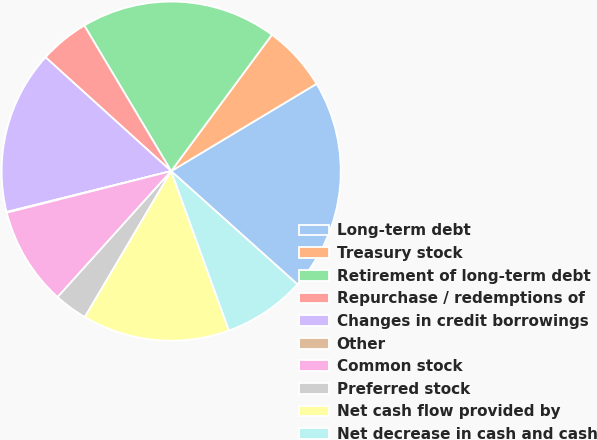Convert chart to OTSL. <chart><loc_0><loc_0><loc_500><loc_500><pie_chart><fcel>Long-term debt<fcel>Treasury stock<fcel>Retirement of long-term debt<fcel>Repurchase / redemptions of<fcel>Changes in credit borrowings<fcel>Other<fcel>Common stock<fcel>Preferred stock<fcel>Net cash flow provided by<fcel>Net decrease in cash and cash<nl><fcel>20.24%<fcel>6.27%<fcel>18.69%<fcel>4.72%<fcel>15.59%<fcel>0.07%<fcel>9.38%<fcel>3.17%<fcel>14.04%<fcel>7.83%<nl></chart> 